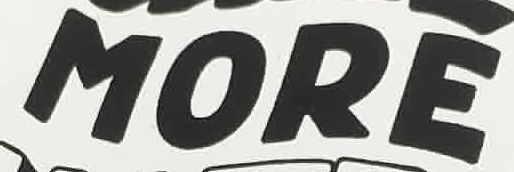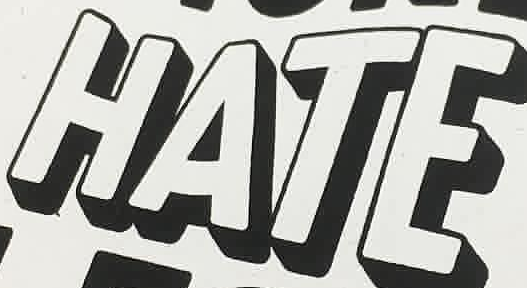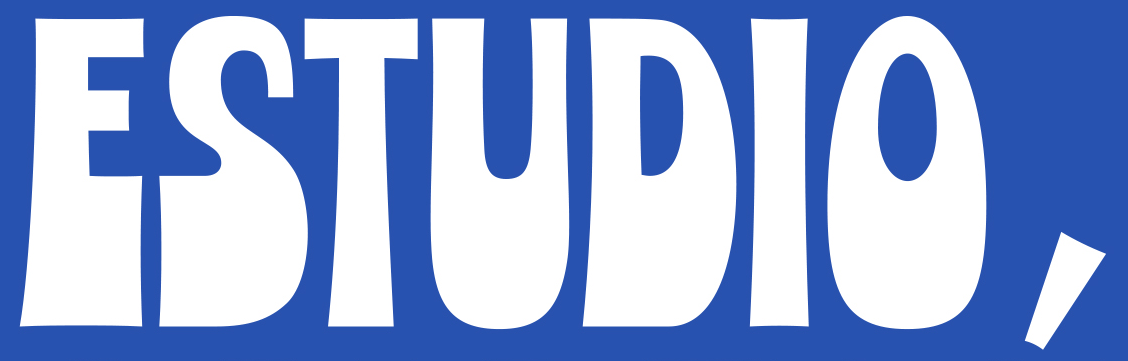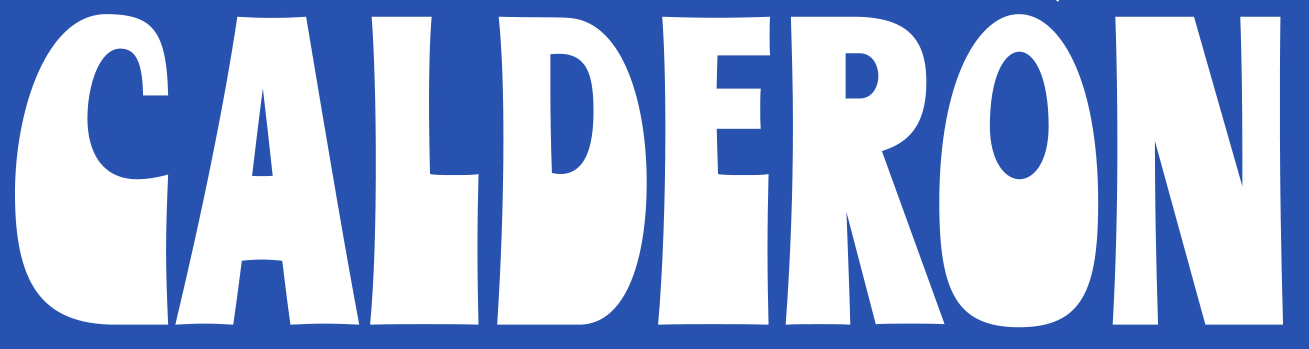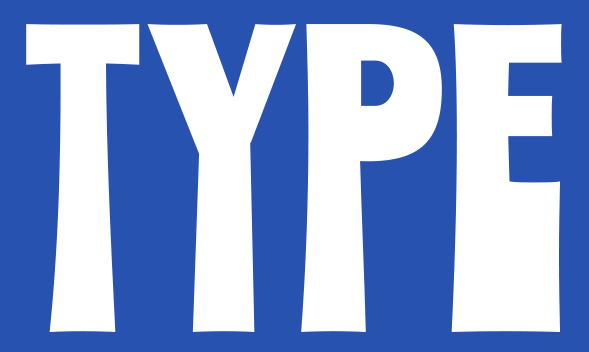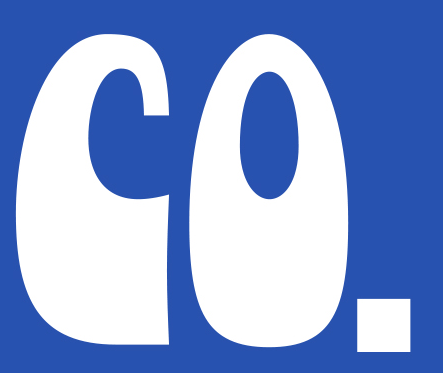Read the text content from these images in order, separated by a semicolon. MORE; HATE; ESTUDIO,; CALDERON; TYPE; CO. 